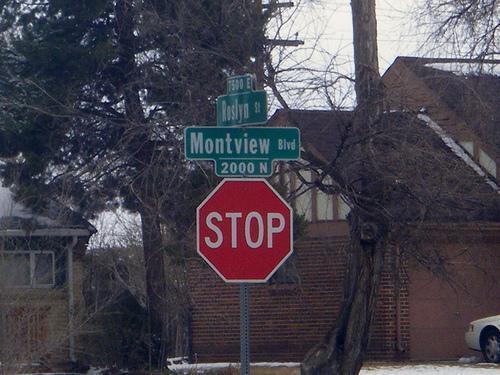How many stop signs are in the picture?
Give a very brief answer. 1. 